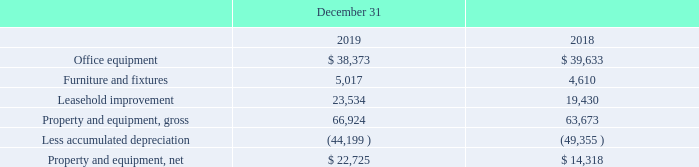Property and Equipment
Property and equipment is recorded at cost and consists of furniture, computers, other office equipment, and leasehold improvements. We depreciate the cost of furniture, computers, and other office equipment on a straight-line basis over their estimated useful lives (five years for office equipment, seven years for furniture and fixtures). Leasehold improvements are depreciated over the lesser of their useful lives or the term of the lease. Depreciation and amortization expense for 2019, 2018, and 2017 was approximately $8.0 million, $8.6 million, and $9.1 million, respectively, and was included in “Depreciation and amortization” in the Consolidated Statements of Income. Amortization expense on intangible assets in 2019, 2018 and 2017 was immaterial.
Property and equipment, at cost, consist of the following (in thousands):
How is the leasehold improvement depreciated? Over the lesser of their useful lives or the term of the lease. What consists of property and equipment cost? Furniture, computers, other office equipment, and leasehold improvements. What is the property and equipment, net in 2019?
Answer scale should be: thousand. 22,725. What is the change in depreciation and amortization cost between 2019 and 2018?
Answer scale should be: million. $8.6-8.0
Answer: 0.6. What is the change in office equipment cost in 2019 and 2018?
Answer scale should be: thousand. $39,633-38,373
Answer: 1260. What is the change in property and equipment, net cost in 2019 and 2018?
Answer scale should be: thousand. $22,725-$14,318
Answer: 8407. 